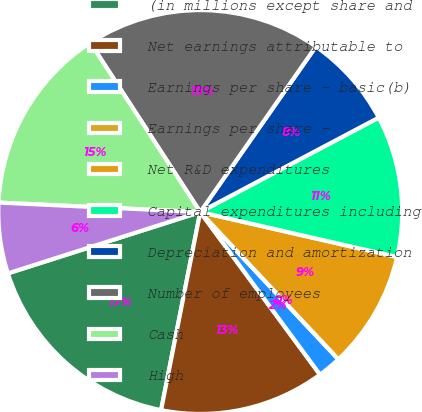<chart> <loc_0><loc_0><loc_500><loc_500><pie_chart><fcel>(in millions except share and<fcel>Net earnings attributable to<fcel>Earnings per share - basic(b)<fcel>Earnings per share -<fcel>Net R&D expenditures<fcel>Capital expenditures including<fcel>Depreciation and amortization<fcel>Number of employees<fcel>Cash<fcel>High<nl><fcel>16.98%<fcel>13.21%<fcel>1.89%<fcel>0.0%<fcel>9.43%<fcel>11.32%<fcel>7.55%<fcel>18.87%<fcel>15.09%<fcel>5.66%<nl></chart> 